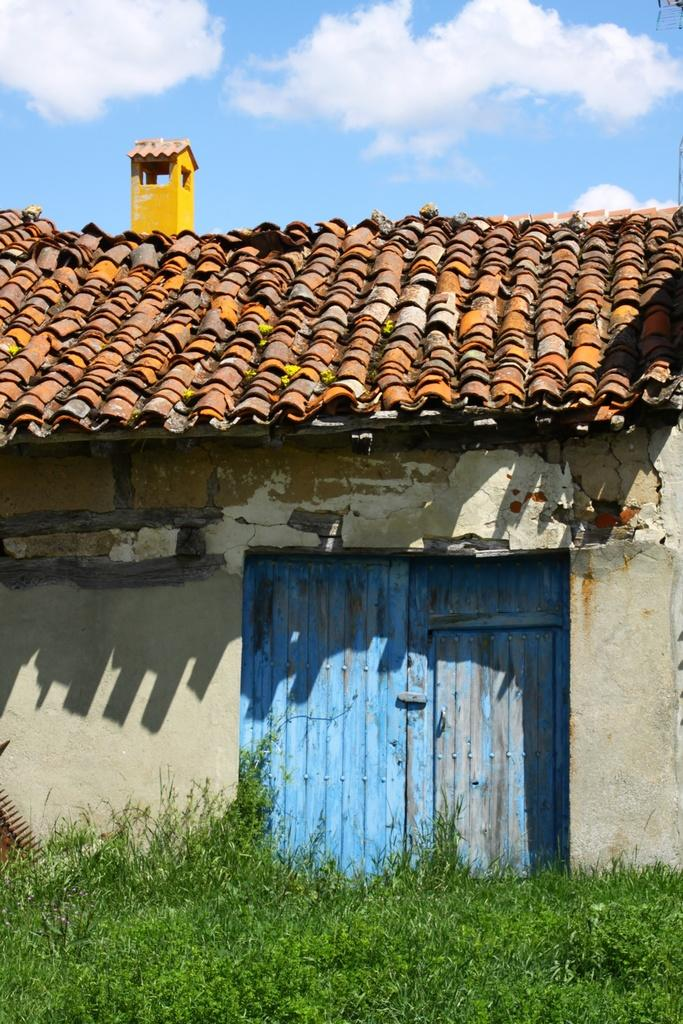What is the main subject in the center of the image? There is a house in the center of the image. What type of vegetation is at the bottom of the image? There is grass at the bottom of the image. What feature is present in the center of the house? The house has a door in the center. What is visible at the top of the image? The sky is visible at the top of the image. How many frogs are sitting on the roof of the house in the image? There are no frogs present in the image; the house has no frogs sitting on its roof. 